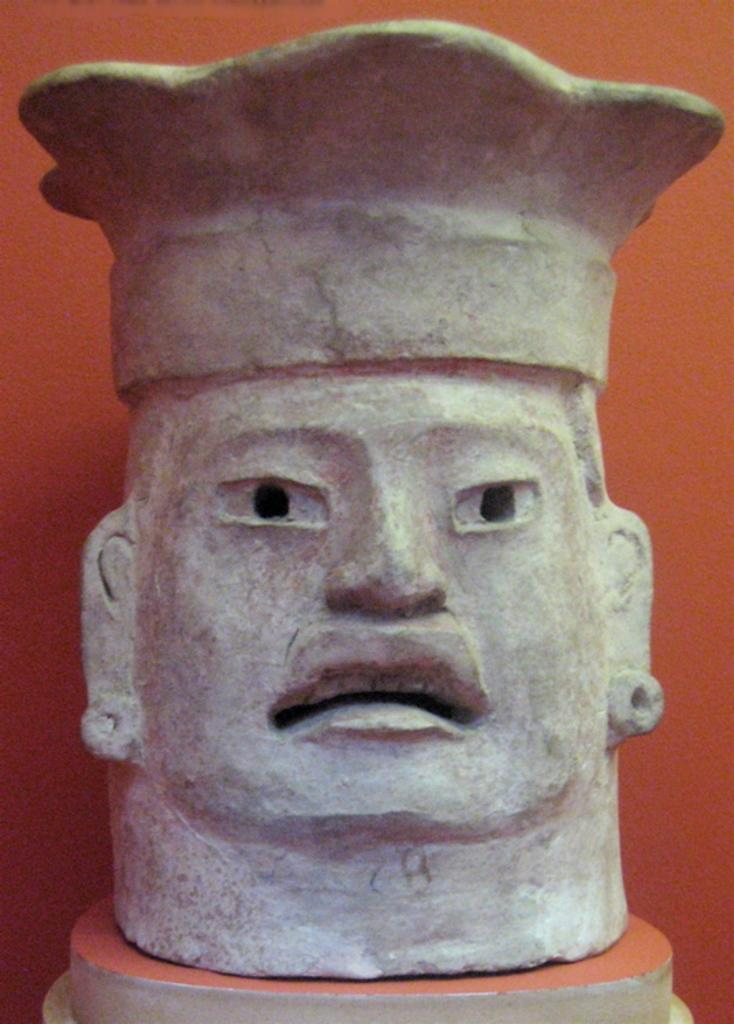What can be seen in the background of the image? There is a wall in the background of the image. What is the main subject of the image? The main subject of the image is a carving on a stone. How is the stone positioned in the image? The stone is placed on a pedestal. What type of ink is used for the carving on the stone? There is no mention of ink in the image, as the carving is likely made by chiseling or engraving the stone. 